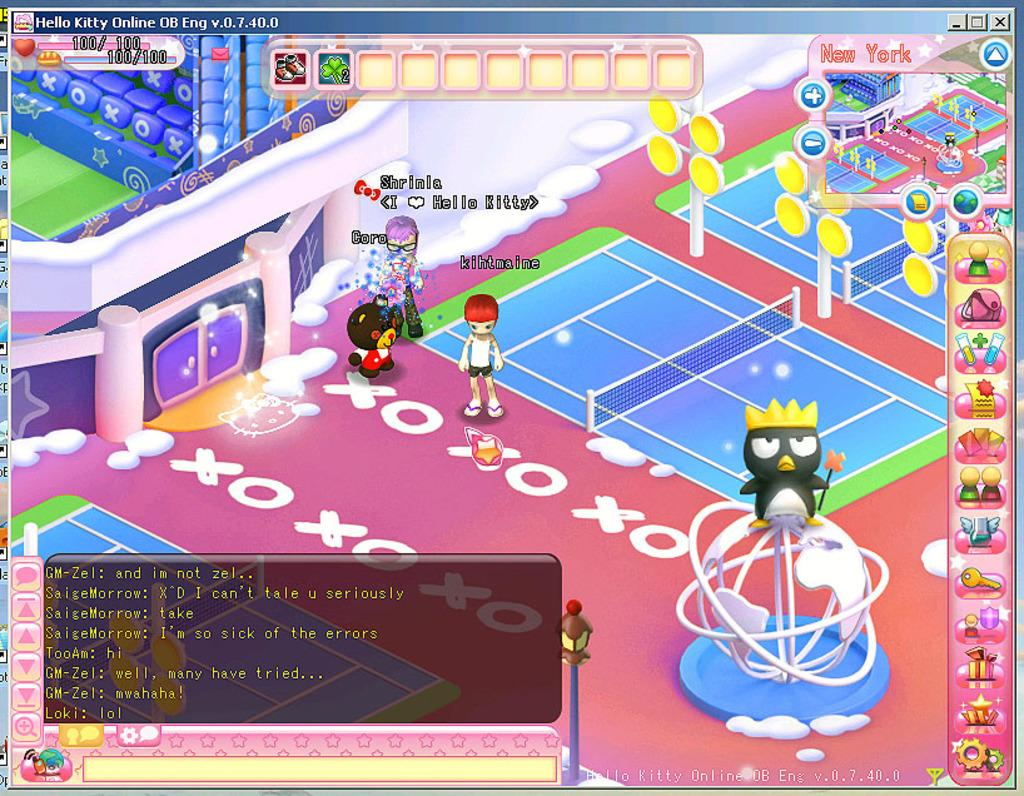What is the main subject of the image? The image depicts a game. What type of characters are featured in the game? There are cartoons in the image. Is there any text present in the image? Yes, text is present in the image. What type of needle is used by the cartoon character in the image? There is no needle present in the image; it features a game with cartoon characters and text. 